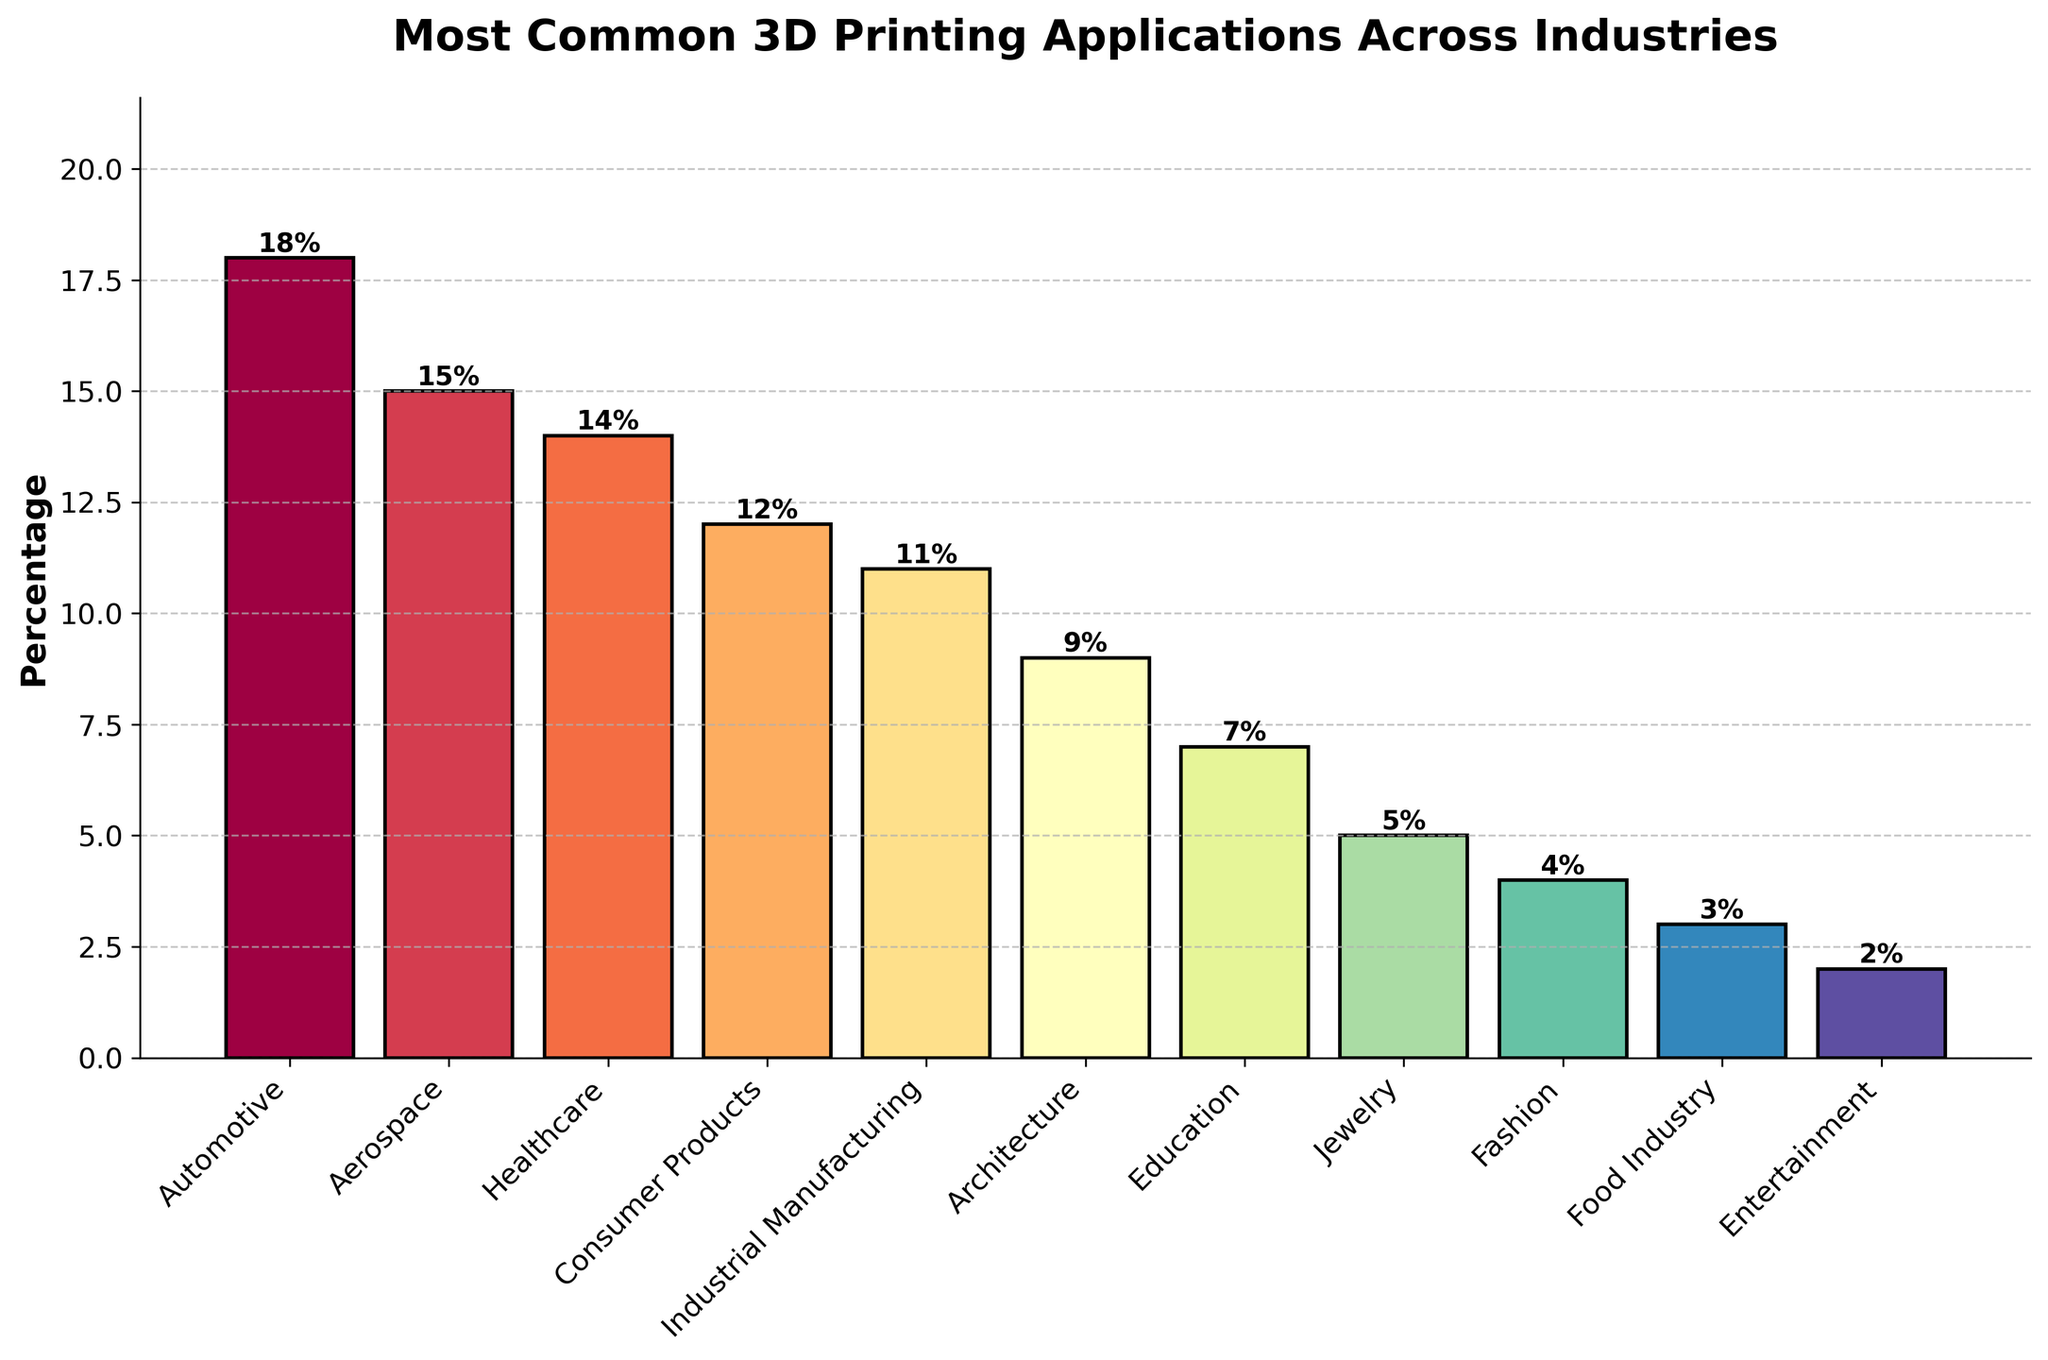What are the top three industries using 3D printing? The top three industries have the highest percentage values in the chart. They are the Automotive industry (18%), Aerospace (15%), and Healthcare (14%).
Answer: Automotive, Aerospace, Healthcare Which industry uses 3D printing less, Fashion or Food Industry? By comparing the percentage values for Fashion (4%) and Food Industry (3%), we can see that the Food Industry uses 3D printing less.
Answer: Food Industry What is the combined percentage of 3D printing applications in the Automotive and Aerospace industries? Add the percentages for the Automotive (18%) and Aerospace (15%) industries: 18 + 15 = 33.
Answer: 33% How much more is the percentage of 3D printing applications in Industrial Manufacturing than in Jewelry? Subtract the percentage for Jewelry (5%) from the percentage for Industrial Manufacturing (11%): 11 - 5 = 6.
Answer: 6% What is the median percentage value of 3D printing applications across all industries? The percentages ordered from smallest to largest are: 2, 3, 4, 5, 7, 9, 11, 12, 14, 15, 18. The median value is the middle one: (9 + 11) / 2 = 10.
Answer: 10% Which industry has a lower percentage of 3D printing applications, Architecture or Education? Comparing the percentages for Architecture (9%) and Education (7%) shows that Education has a lower percentage.
Answer: Education What is the total percentage of 3D printing applications in Consumer Products, Entertainment, and Healthcare industries combined? Add the percentages for Consumer Products (12%), Entertainment (2%), and Healthcare (14%): 12 + 2 + 14 = 28.
Answer: 28% What percentage of 3D printing applications does the Entertainment industry have? The percentage for the Entertainment industry is directly shown on the chart, which is 2%.
Answer: 2% How does the height of the bar for the Automotive industry compare to that for the Fashion industry visually? The height of the bar for the Automotive industry (18%) is significantly taller than that for the Fashion industry (4%), indicating a higher percentage.
Answer: Taller Which industry has a higher 3D printing application percentage, Consumer Products or Healthcare? Comparing the percentages for Consumer Products (12%) and Healthcare (14%) shows that Healthcare has a higher percentage.
Answer: Healthcare 